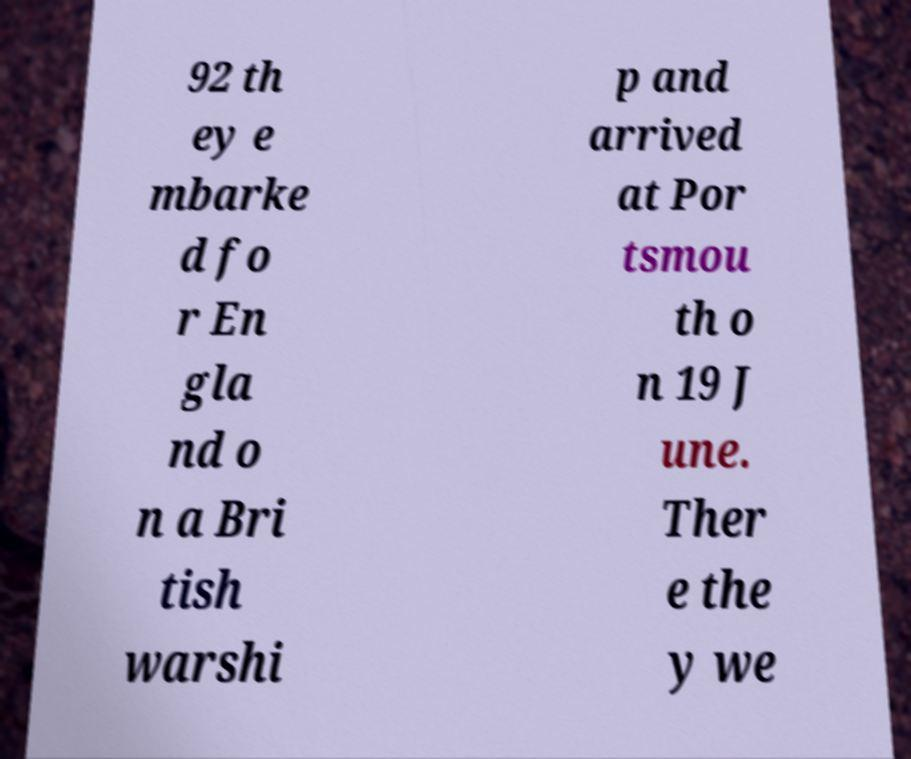There's text embedded in this image that I need extracted. Can you transcribe it verbatim? 92 th ey e mbarke d fo r En gla nd o n a Bri tish warshi p and arrived at Por tsmou th o n 19 J une. Ther e the y we 